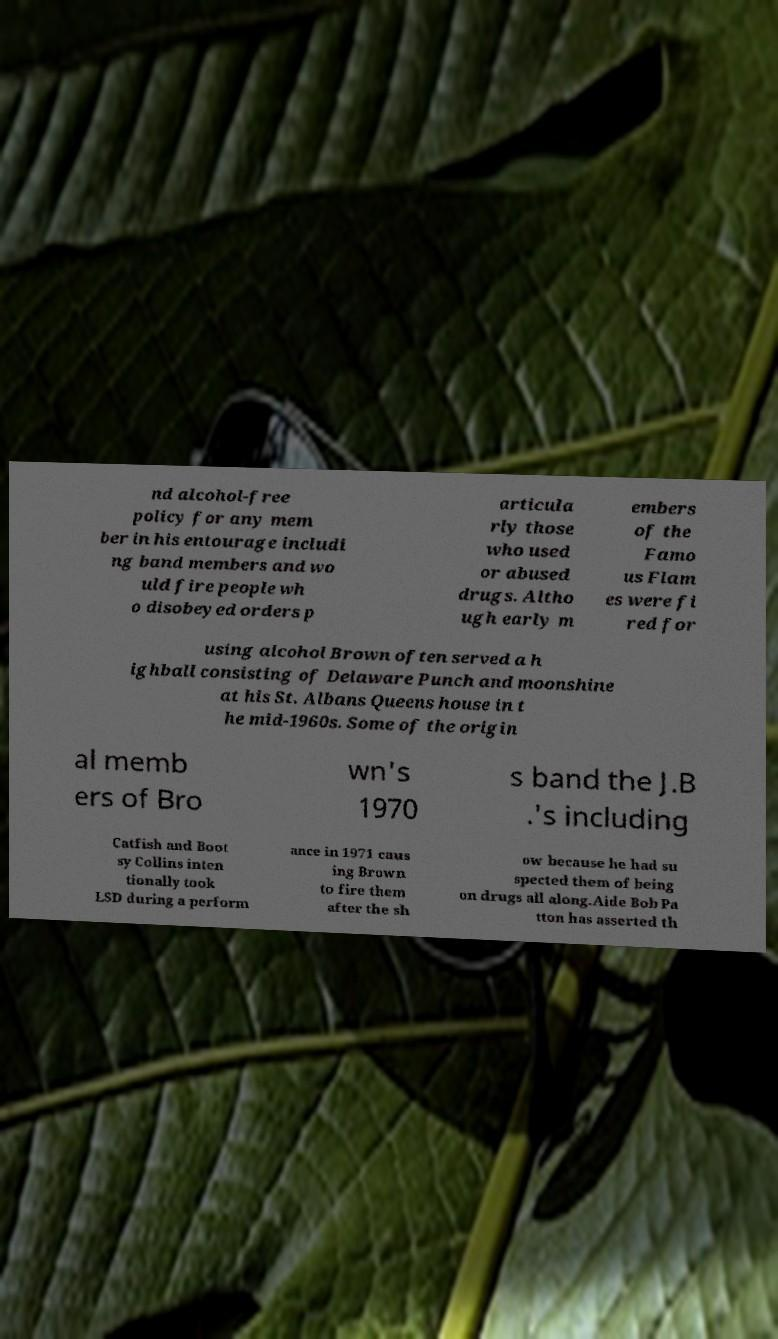For documentation purposes, I need the text within this image transcribed. Could you provide that? nd alcohol-free policy for any mem ber in his entourage includi ng band members and wo uld fire people wh o disobeyed orders p articula rly those who used or abused drugs. Altho ugh early m embers of the Famo us Flam es were fi red for using alcohol Brown often served a h ighball consisting of Delaware Punch and moonshine at his St. Albans Queens house in t he mid-1960s. Some of the origin al memb ers of Bro wn's 1970 s band the J.B .'s including Catfish and Boot sy Collins inten tionally took LSD during a perform ance in 1971 caus ing Brown to fire them after the sh ow because he had su spected them of being on drugs all along.Aide Bob Pa tton has asserted th 